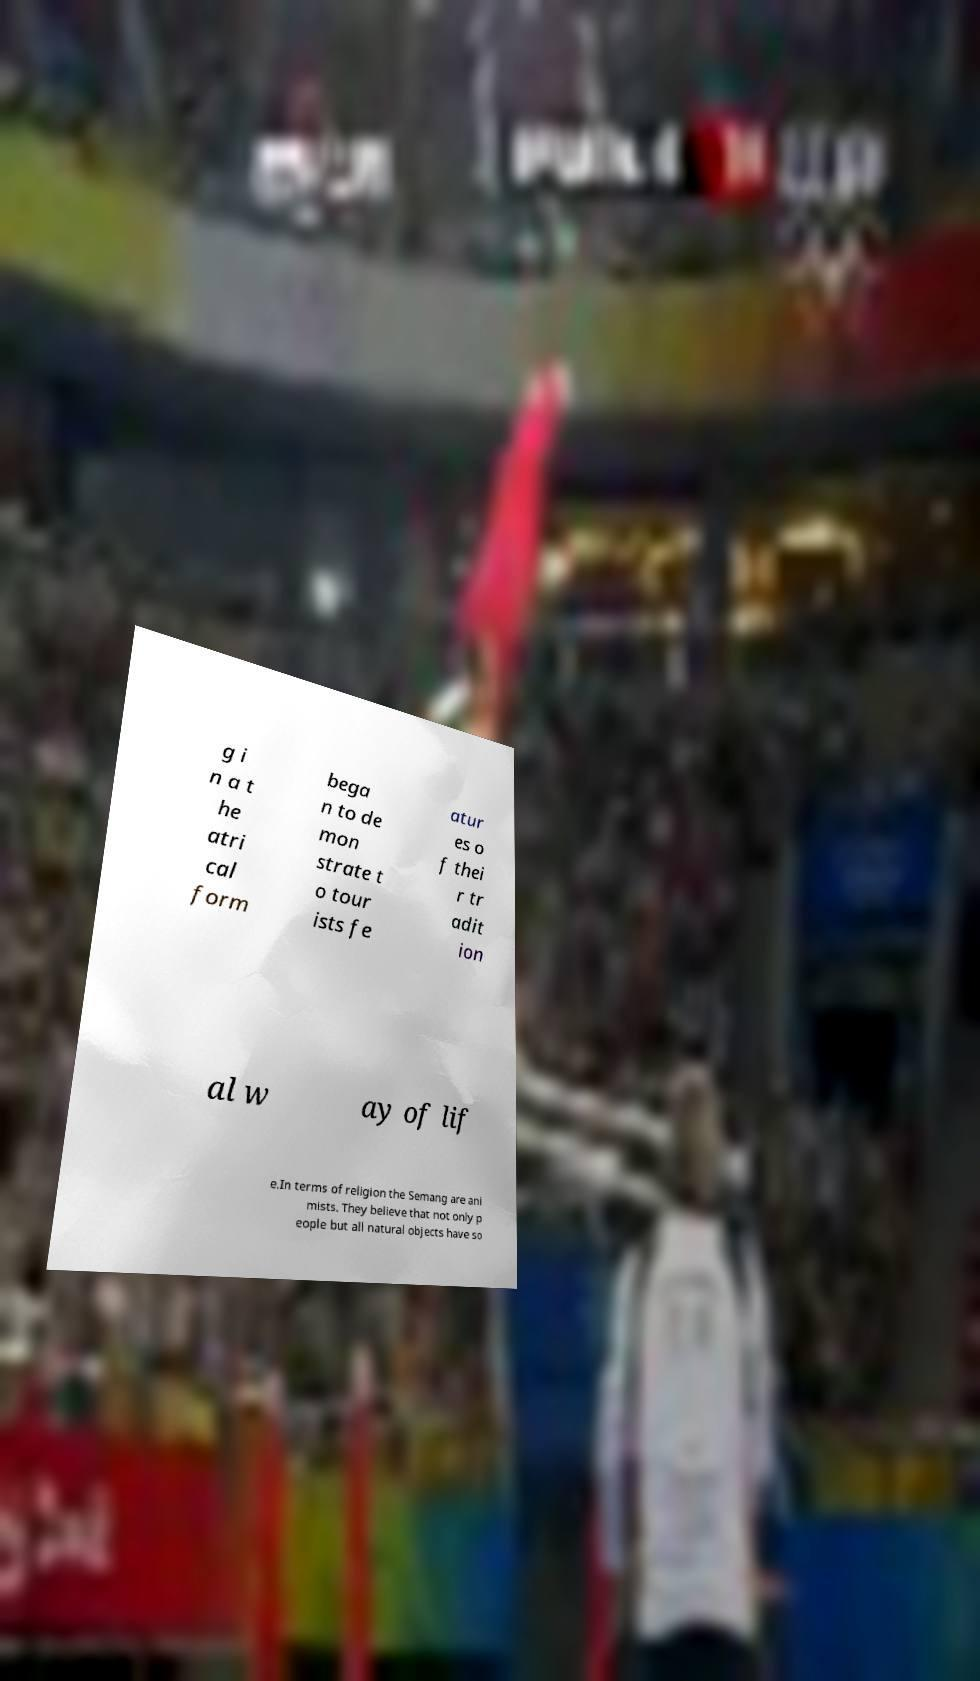Please identify and transcribe the text found in this image. g i n a t he atri cal form bega n to de mon strate t o tour ists fe atur es o f thei r tr adit ion al w ay of lif e.In terms of religion the Semang are ani mists. They believe that not only p eople but all natural objects have so 